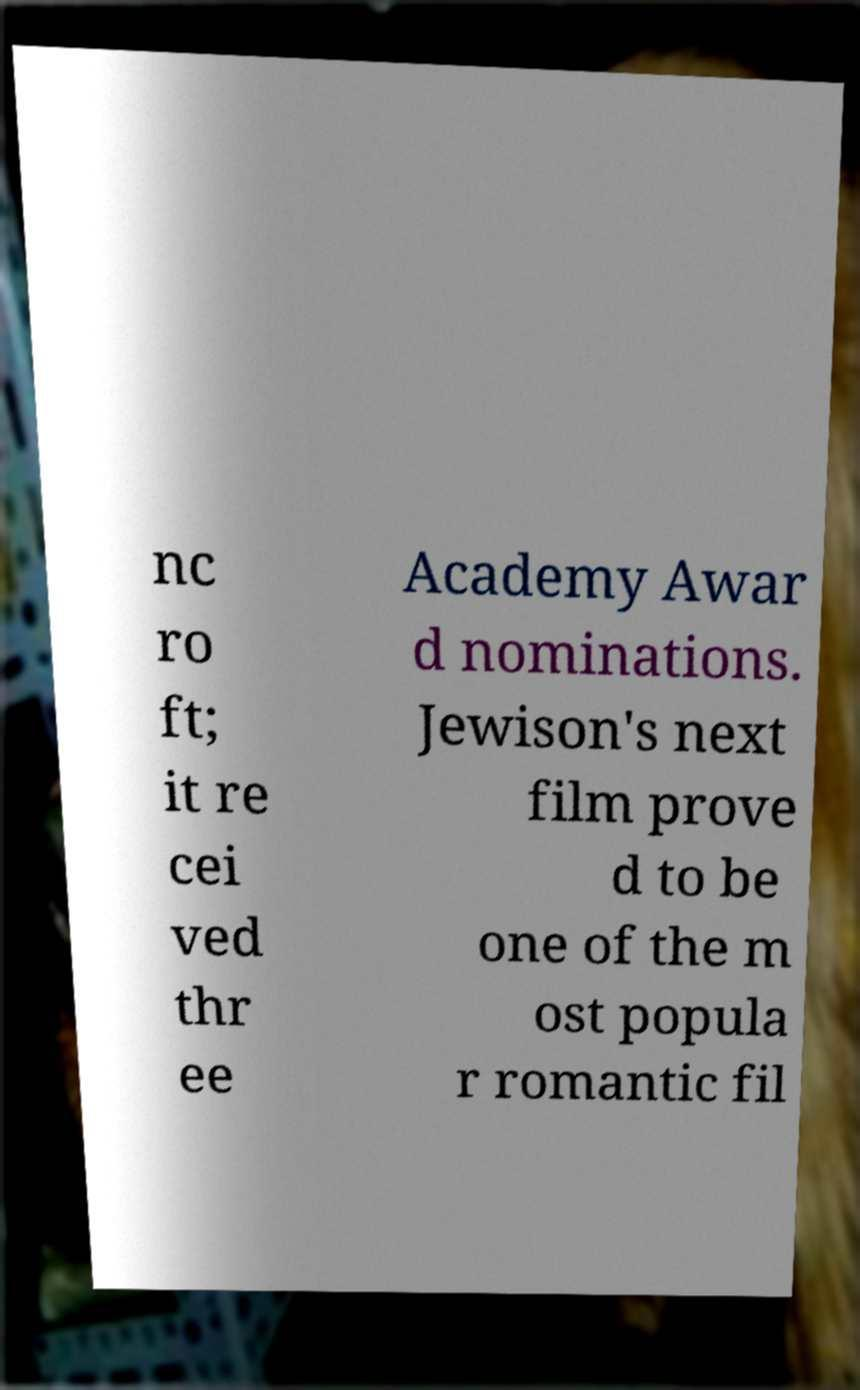There's text embedded in this image that I need extracted. Can you transcribe it verbatim? nc ro ft; it re cei ved thr ee Academy Awar d nominations. Jewison's next film prove d to be one of the m ost popula r romantic fil 